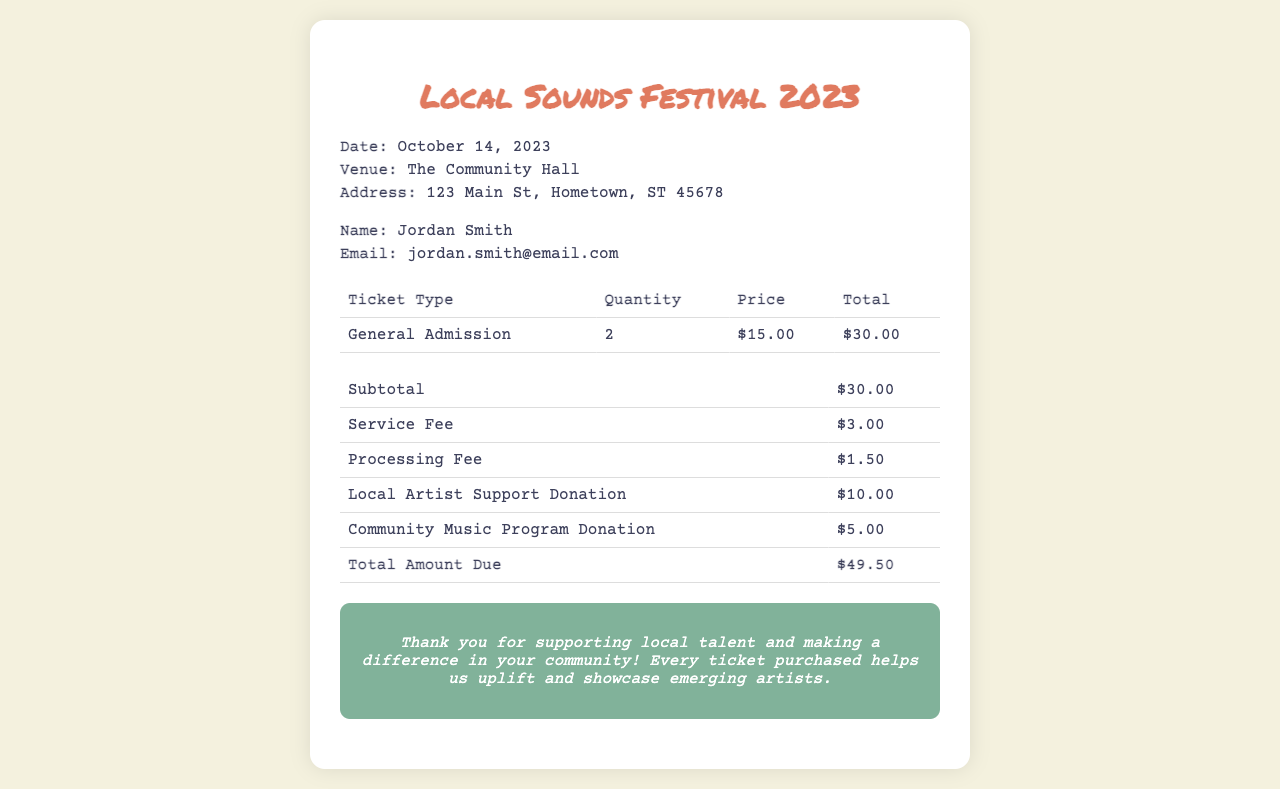What is the date of the event? The date of the event is explicitly stated in the document under event details.
Answer: October 14, 2023 What is the name of the attendee? The name of the attendee is found in the attendee details section of the receipt.
Answer: Jordan Smith How much is the General Admission ticket? The price for General Admission is listed in the ticket details table.
Answer: $15.00 What is the total amount due? The total amount due is the final figure presented at the bottom of the cost breakdown table.
Answer: $49.50 How much is the service fee? The service fee is specifically mentioned in the cost breakdown section of the receipt.
Answer: $3.00 How many General Admission tickets were purchased? The quantity of tickets is noted in the ticket details section.
Answer: 2 What is one of the donation amounts included in this receipt? The receipt includes donation amounts for local artist support and community programs, which can be found in the cost breakdown section.
Answer: $10.00 What venue is hosting the Local Sounds Festival? The venue hosting the event is detailed in the event details part of the receipt.
Answer: The Community Hall What is the total of fees excluding donations? The total of fees excluding donations can be calculated by summing the subtotal, service fee, and processing fee.
Answer: $34.50 